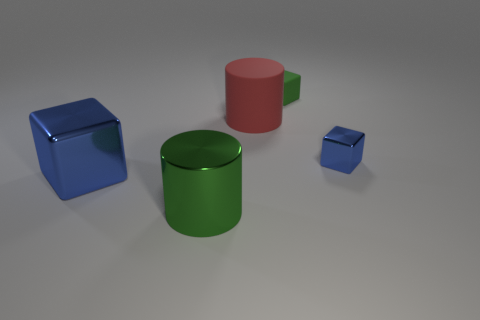What size is the block that is to the right of the big red cylinder and in front of the green rubber cube?
Provide a short and direct response. Small. Are there more big blue blocks in front of the tiny green matte block than large things in front of the large green thing?
Offer a very short reply. Yes. What is the size of the other metallic object that is the same color as the tiny shiny thing?
Give a very brief answer. Large. The large shiny block is what color?
Make the answer very short. Blue. The block that is to the left of the tiny blue metal object and in front of the green rubber thing is what color?
Your answer should be compact. Blue. What color is the tiny thing that is to the left of the blue metallic cube that is behind the blue shiny object that is to the left of the red rubber cylinder?
Provide a short and direct response. Green. There is a block that is the same size as the matte cylinder; what color is it?
Provide a succinct answer. Blue. What is the shape of the object on the left side of the object that is in front of the blue shiny object left of the green matte object?
Provide a short and direct response. Cube. There is a big shiny thing that is the same color as the rubber block; what shape is it?
Your response must be concise. Cylinder. What number of things are cylinders or blue blocks right of the large green thing?
Your answer should be very brief. 3. 